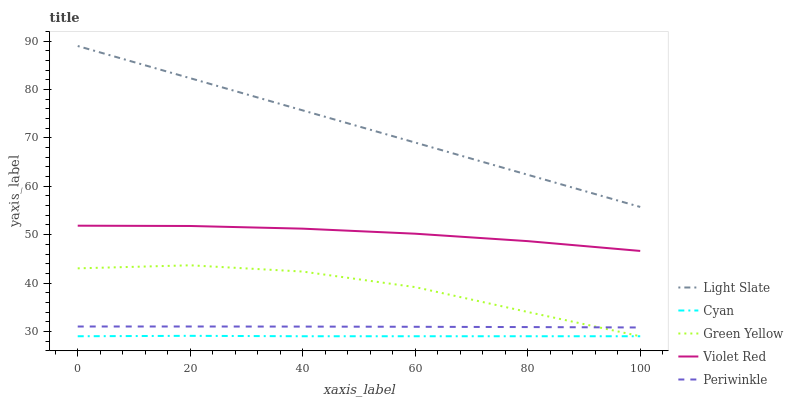Does Cyan have the minimum area under the curve?
Answer yes or no. Yes. Does Light Slate have the maximum area under the curve?
Answer yes or no. Yes. Does Violet Red have the minimum area under the curve?
Answer yes or no. No. Does Violet Red have the maximum area under the curve?
Answer yes or no. No. Is Light Slate the smoothest?
Answer yes or no. Yes. Is Green Yellow the roughest?
Answer yes or no. Yes. Is Cyan the smoothest?
Answer yes or no. No. Is Cyan the roughest?
Answer yes or no. No. Does Cyan have the lowest value?
Answer yes or no. Yes. Does Violet Red have the lowest value?
Answer yes or no. No. Does Light Slate have the highest value?
Answer yes or no. Yes. Does Violet Red have the highest value?
Answer yes or no. No. Is Green Yellow less than Light Slate?
Answer yes or no. Yes. Is Light Slate greater than Green Yellow?
Answer yes or no. Yes. Does Green Yellow intersect Cyan?
Answer yes or no. Yes. Is Green Yellow less than Cyan?
Answer yes or no. No. Is Green Yellow greater than Cyan?
Answer yes or no. No. Does Green Yellow intersect Light Slate?
Answer yes or no. No. 